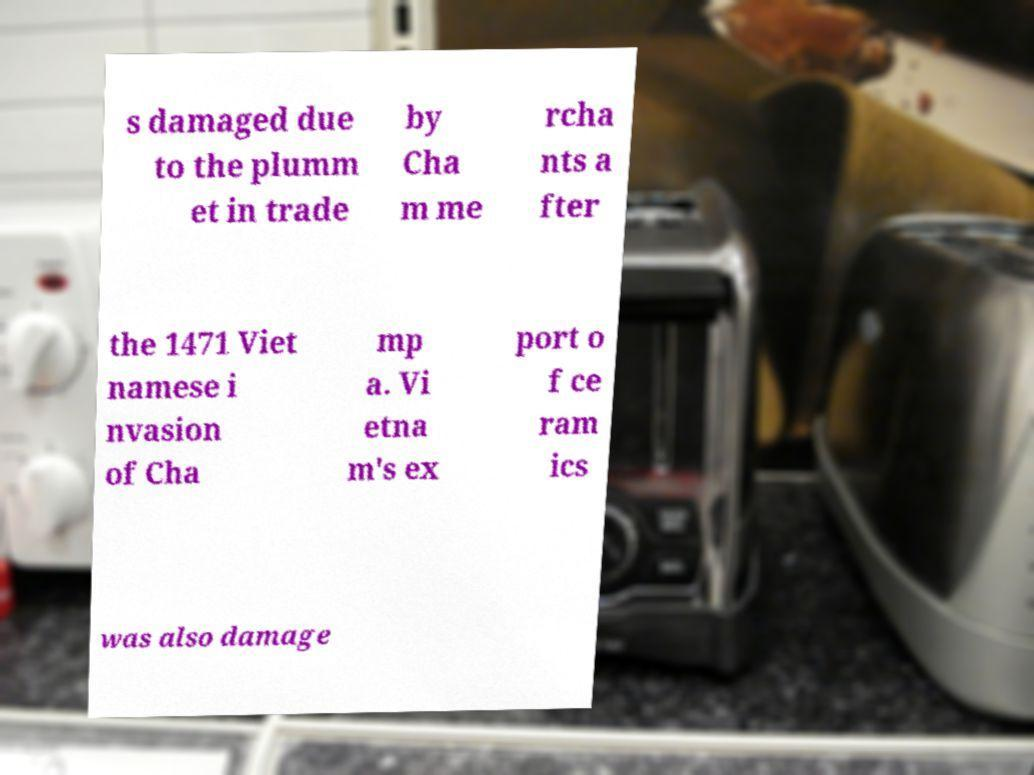Could you assist in decoding the text presented in this image and type it out clearly? s damaged due to the plumm et in trade by Cha m me rcha nts a fter the 1471 Viet namese i nvasion of Cha mp a. Vi etna m's ex port o f ce ram ics was also damage 